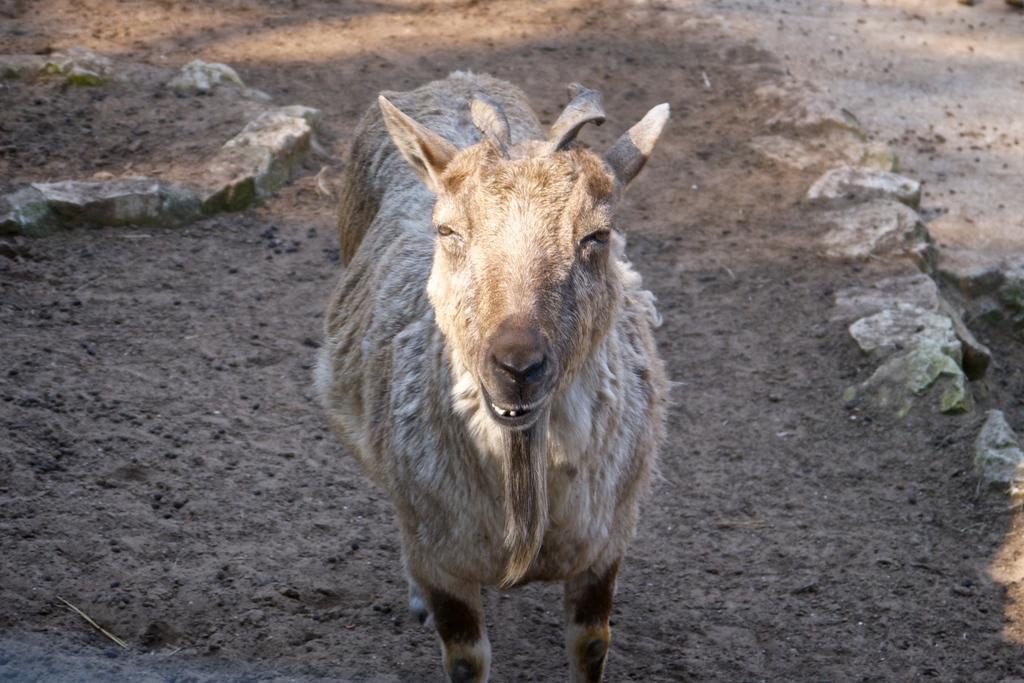Can you describe this image briefly? In this image, we can see a goat is standing on the ground. Here we can see stones. 